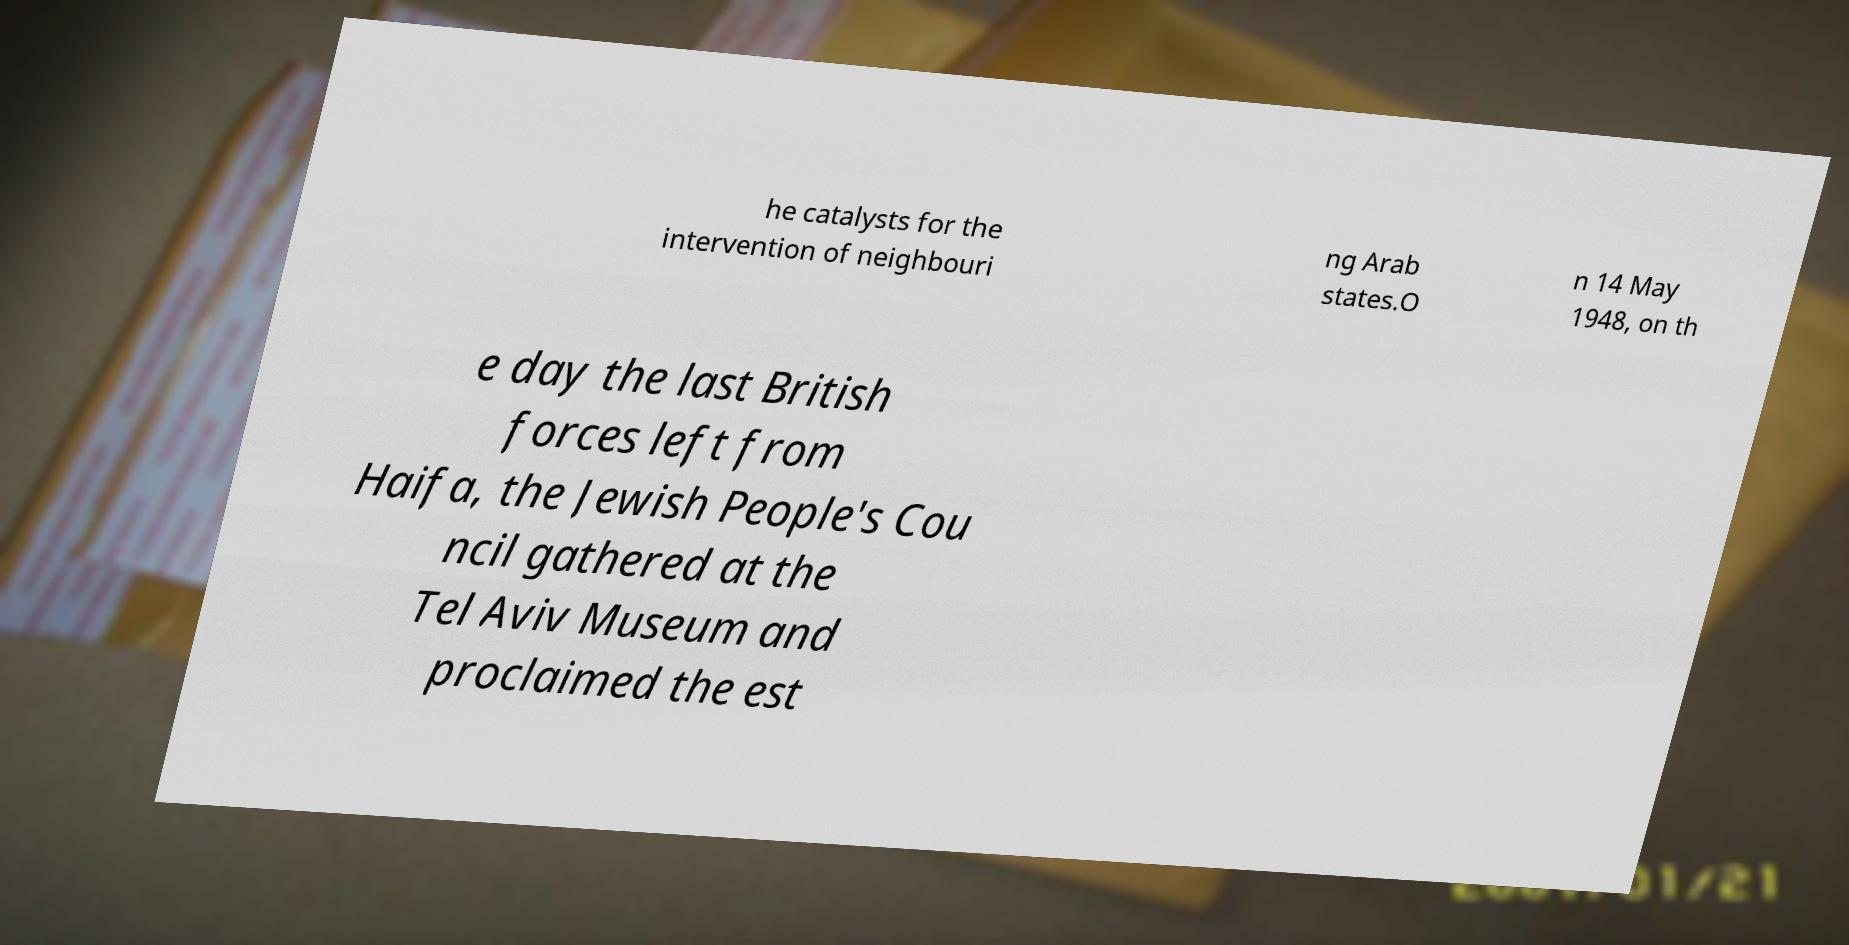What messages or text are displayed in this image? I need them in a readable, typed format. he catalysts for the intervention of neighbouri ng Arab states.O n 14 May 1948, on th e day the last British forces left from Haifa, the Jewish People's Cou ncil gathered at the Tel Aviv Museum and proclaimed the est 